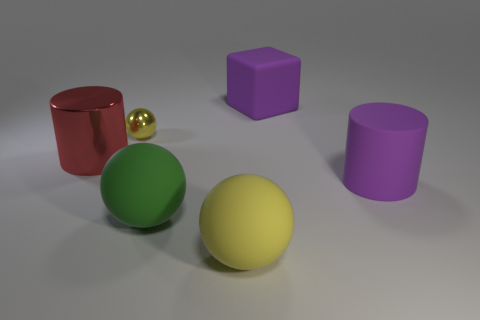Add 1 tiny shiny balls. How many objects exist? 7 Subtract all cubes. How many objects are left? 5 Subtract 1 yellow balls. How many objects are left? 5 Subtract all matte spheres. Subtract all large yellow matte balls. How many objects are left? 3 Add 1 big green rubber things. How many big green rubber things are left? 2 Add 1 red cylinders. How many red cylinders exist? 2 